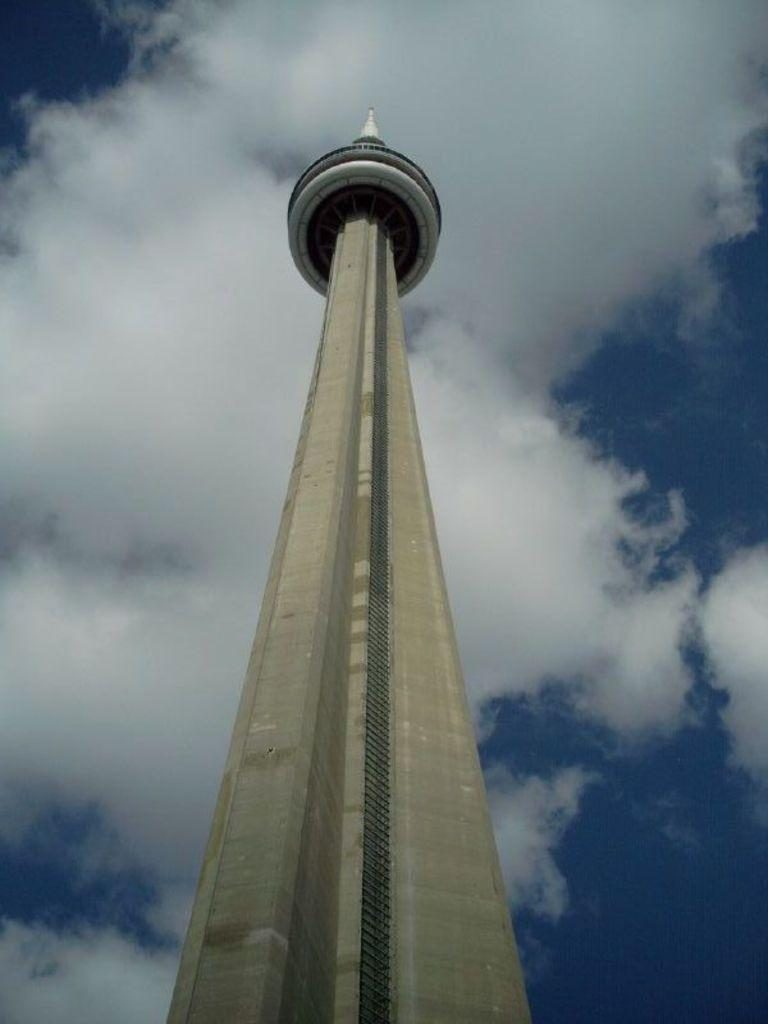What is the main subject of the picture? The main subject of the picture is a tower. Can you describe the tower in the image? The tower is very tall. What is visible in the background of the image? The sky is clear in the background of the image. What list can be seen hanging on the tower in the image? There is no list present in the image; it features a tall tower with a clear sky in the background. What song is being sung by the tower in the image? There is no indication in the image that the tower is singing a song. 